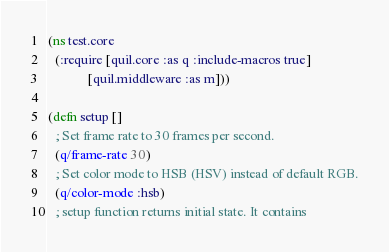<code> <loc_0><loc_0><loc_500><loc_500><_Clojure_>(ns test.core
  (:require [quil.core :as q :include-macros true]
            [quil.middleware :as m]))

(defn setup []
  ; Set frame rate to 30 frames per second.
  (q/frame-rate 30)
  ; Set color mode to HSB (HSV) instead of default RGB.
  (q/color-mode :hsb)
  ; setup function returns initial state. It contains</code> 